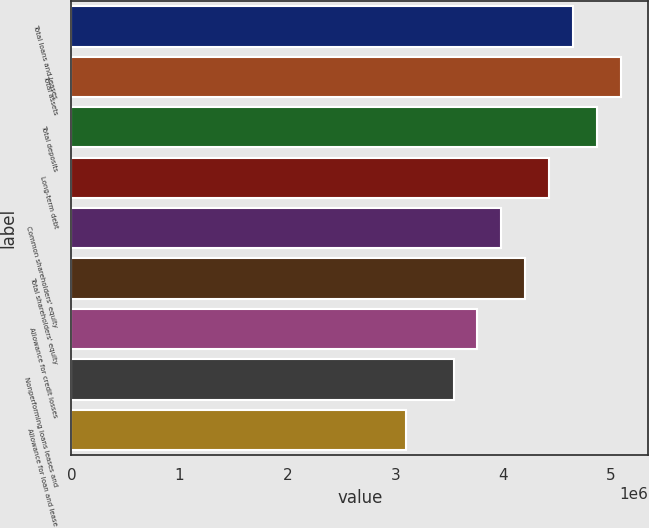Convert chart to OTSL. <chart><loc_0><loc_0><loc_500><loc_500><bar_chart><fcel>Total loans and leases<fcel>Total assets<fcel>Total deposits<fcel>Long-term debt<fcel>Common shareholders' equity<fcel>Total shareholders' equity<fcel>Allowance for credit losses<fcel>Nonperforming loans leases and<fcel>Allowance for loan and lease<nl><fcel>4.6461e+06<fcel>5.08859e+06<fcel>4.86734e+06<fcel>4.42486e+06<fcel>3.98237e+06<fcel>4.20362e+06<fcel>3.76113e+06<fcel>3.53989e+06<fcel>3.0974e+06<nl></chart> 